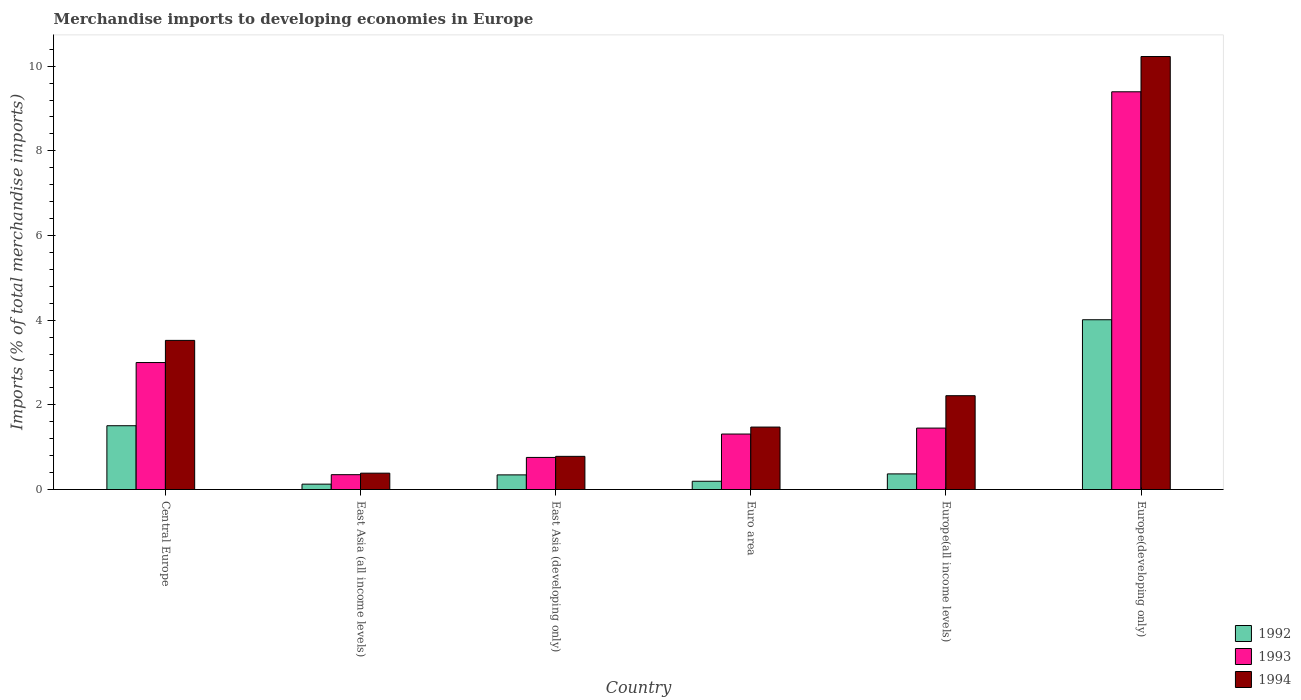How many groups of bars are there?
Provide a short and direct response. 6. How many bars are there on the 5th tick from the left?
Give a very brief answer. 3. What is the label of the 4th group of bars from the left?
Make the answer very short. Euro area. In how many cases, is the number of bars for a given country not equal to the number of legend labels?
Provide a short and direct response. 0. What is the percentage total merchandise imports in 1992 in Euro area?
Your answer should be compact. 0.2. Across all countries, what is the maximum percentage total merchandise imports in 1994?
Your answer should be very brief. 10.23. Across all countries, what is the minimum percentage total merchandise imports in 1992?
Offer a terse response. 0.13. In which country was the percentage total merchandise imports in 1994 maximum?
Ensure brevity in your answer.  Europe(developing only). In which country was the percentage total merchandise imports in 1993 minimum?
Ensure brevity in your answer.  East Asia (all income levels). What is the total percentage total merchandise imports in 1993 in the graph?
Ensure brevity in your answer.  16.26. What is the difference between the percentage total merchandise imports in 1994 in Euro area and that in Europe(developing only)?
Offer a terse response. -8.75. What is the difference between the percentage total merchandise imports in 1993 in East Asia (all income levels) and the percentage total merchandise imports in 1994 in Central Europe?
Your response must be concise. -3.17. What is the average percentage total merchandise imports in 1992 per country?
Offer a terse response. 1.09. What is the difference between the percentage total merchandise imports of/in 1994 and percentage total merchandise imports of/in 1993 in East Asia (developing only)?
Provide a short and direct response. 0.03. In how many countries, is the percentage total merchandise imports in 1992 greater than 9.6 %?
Give a very brief answer. 0. What is the ratio of the percentage total merchandise imports in 1993 in Euro area to that in Europe(developing only)?
Give a very brief answer. 0.14. Is the percentage total merchandise imports in 1994 in Central Europe less than that in Europe(developing only)?
Offer a terse response. Yes. Is the difference between the percentage total merchandise imports in 1994 in Euro area and Europe(developing only) greater than the difference between the percentage total merchandise imports in 1993 in Euro area and Europe(developing only)?
Offer a very short reply. No. What is the difference between the highest and the second highest percentage total merchandise imports in 1992?
Your response must be concise. -1.14. What is the difference between the highest and the lowest percentage total merchandise imports in 1993?
Provide a succinct answer. 9.04. What does the 1st bar from the right in Central Europe represents?
Your answer should be very brief. 1994. Are all the bars in the graph horizontal?
Offer a very short reply. No. How many countries are there in the graph?
Offer a terse response. 6. Are the values on the major ticks of Y-axis written in scientific E-notation?
Make the answer very short. No. Does the graph contain any zero values?
Provide a succinct answer. No. Does the graph contain grids?
Provide a short and direct response. No. Where does the legend appear in the graph?
Offer a very short reply. Bottom right. How many legend labels are there?
Provide a succinct answer. 3. What is the title of the graph?
Your response must be concise. Merchandise imports to developing economies in Europe. Does "1983" appear as one of the legend labels in the graph?
Offer a terse response. No. What is the label or title of the Y-axis?
Offer a terse response. Imports (% of total merchandise imports). What is the Imports (% of total merchandise imports) of 1992 in Central Europe?
Your answer should be compact. 1.51. What is the Imports (% of total merchandise imports) in 1993 in Central Europe?
Your answer should be very brief. 3. What is the Imports (% of total merchandise imports) of 1994 in Central Europe?
Offer a terse response. 3.52. What is the Imports (% of total merchandise imports) of 1992 in East Asia (all income levels)?
Offer a terse response. 0.13. What is the Imports (% of total merchandise imports) of 1993 in East Asia (all income levels)?
Offer a very short reply. 0.35. What is the Imports (% of total merchandise imports) in 1994 in East Asia (all income levels)?
Provide a succinct answer. 0.39. What is the Imports (% of total merchandise imports) of 1992 in East Asia (developing only)?
Your answer should be very brief. 0.35. What is the Imports (% of total merchandise imports) of 1993 in East Asia (developing only)?
Give a very brief answer. 0.76. What is the Imports (% of total merchandise imports) of 1994 in East Asia (developing only)?
Your answer should be very brief. 0.78. What is the Imports (% of total merchandise imports) of 1992 in Euro area?
Make the answer very short. 0.2. What is the Imports (% of total merchandise imports) in 1993 in Euro area?
Ensure brevity in your answer.  1.31. What is the Imports (% of total merchandise imports) of 1994 in Euro area?
Offer a terse response. 1.48. What is the Imports (% of total merchandise imports) of 1992 in Europe(all income levels)?
Your response must be concise. 0.37. What is the Imports (% of total merchandise imports) of 1993 in Europe(all income levels)?
Offer a terse response. 1.45. What is the Imports (% of total merchandise imports) in 1994 in Europe(all income levels)?
Your response must be concise. 2.22. What is the Imports (% of total merchandise imports) in 1992 in Europe(developing only)?
Offer a terse response. 4.01. What is the Imports (% of total merchandise imports) of 1993 in Europe(developing only)?
Give a very brief answer. 9.39. What is the Imports (% of total merchandise imports) of 1994 in Europe(developing only)?
Give a very brief answer. 10.23. Across all countries, what is the maximum Imports (% of total merchandise imports) in 1992?
Provide a succinct answer. 4.01. Across all countries, what is the maximum Imports (% of total merchandise imports) in 1993?
Provide a short and direct response. 9.39. Across all countries, what is the maximum Imports (% of total merchandise imports) of 1994?
Ensure brevity in your answer.  10.23. Across all countries, what is the minimum Imports (% of total merchandise imports) of 1992?
Provide a succinct answer. 0.13. Across all countries, what is the minimum Imports (% of total merchandise imports) in 1993?
Offer a very short reply. 0.35. Across all countries, what is the minimum Imports (% of total merchandise imports) of 1994?
Your response must be concise. 0.39. What is the total Imports (% of total merchandise imports) in 1992 in the graph?
Ensure brevity in your answer.  6.55. What is the total Imports (% of total merchandise imports) in 1993 in the graph?
Give a very brief answer. 16.26. What is the total Imports (% of total merchandise imports) of 1994 in the graph?
Give a very brief answer. 18.61. What is the difference between the Imports (% of total merchandise imports) in 1992 in Central Europe and that in East Asia (all income levels)?
Provide a short and direct response. 1.38. What is the difference between the Imports (% of total merchandise imports) in 1993 in Central Europe and that in East Asia (all income levels)?
Offer a very short reply. 2.65. What is the difference between the Imports (% of total merchandise imports) of 1994 in Central Europe and that in East Asia (all income levels)?
Make the answer very short. 3.14. What is the difference between the Imports (% of total merchandise imports) in 1992 in Central Europe and that in East Asia (developing only)?
Provide a short and direct response. 1.16. What is the difference between the Imports (% of total merchandise imports) in 1993 in Central Europe and that in East Asia (developing only)?
Your answer should be very brief. 2.24. What is the difference between the Imports (% of total merchandise imports) of 1994 in Central Europe and that in East Asia (developing only)?
Give a very brief answer. 2.74. What is the difference between the Imports (% of total merchandise imports) in 1992 in Central Europe and that in Euro area?
Offer a very short reply. 1.31. What is the difference between the Imports (% of total merchandise imports) in 1993 in Central Europe and that in Euro area?
Provide a succinct answer. 1.69. What is the difference between the Imports (% of total merchandise imports) of 1994 in Central Europe and that in Euro area?
Provide a succinct answer. 2.05. What is the difference between the Imports (% of total merchandise imports) of 1992 in Central Europe and that in Europe(all income levels)?
Offer a terse response. 1.14. What is the difference between the Imports (% of total merchandise imports) of 1993 in Central Europe and that in Europe(all income levels)?
Your response must be concise. 1.55. What is the difference between the Imports (% of total merchandise imports) in 1994 in Central Europe and that in Europe(all income levels)?
Your answer should be compact. 1.31. What is the difference between the Imports (% of total merchandise imports) in 1992 in Central Europe and that in Europe(developing only)?
Offer a terse response. -2.5. What is the difference between the Imports (% of total merchandise imports) of 1993 in Central Europe and that in Europe(developing only)?
Keep it short and to the point. -6.4. What is the difference between the Imports (% of total merchandise imports) in 1994 in Central Europe and that in Europe(developing only)?
Provide a short and direct response. -6.7. What is the difference between the Imports (% of total merchandise imports) in 1992 in East Asia (all income levels) and that in East Asia (developing only)?
Keep it short and to the point. -0.22. What is the difference between the Imports (% of total merchandise imports) of 1993 in East Asia (all income levels) and that in East Asia (developing only)?
Your response must be concise. -0.41. What is the difference between the Imports (% of total merchandise imports) of 1994 in East Asia (all income levels) and that in East Asia (developing only)?
Ensure brevity in your answer.  -0.4. What is the difference between the Imports (% of total merchandise imports) of 1992 in East Asia (all income levels) and that in Euro area?
Give a very brief answer. -0.07. What is the difference between the Imports (% of total merchandise imports) of 1993 in East Asia (all income levels) and that in Euro area?
Give a very brief answer. -0.96. What is the difference between the Imports (% of total merchandise imports) in 1994 in East Asia (all income levels) and that in Euro area?
Ensure brevity in your answer.  -1.09. What is the difference between the Imports (% of total merchandise imports) of 1992 in East Asia (all income levels) and that in Europe(all income levels)?
Provide a succinct answer. -0.24. What is the difference between the Imports (% of total merchandise imports) of 1993 in East Asia (all income levels) and that in Europe(all income levels)?
Your response must be concise. -1.1. What is the difference between the Imports (% of total merchandise imports) of 1994 in East Asia (all income levels) and that in Europe(all income levels)?
Your answer should be very brief. -1.83. What is the difference between the Imports (% of total merchandise imports) of 1992 in East Asia (all income levels) and that in Europe(developing only)?
Keep it short and to the point. -3.88. What is the difference between the Imports (% of total merchandise imports) of 1993 in East Asia (all income levels) and that in Europe(developing only)?
Ensure brevity in your answer.  -9.04. What is the difference between the Imports (% of total merchandise imports) of 1994 in East Asia (all income levels) and that in Europe(developing only)?
Offer a terse response. -9.84. What is the difference between the Imports (% of total merchandise imports) of 1992 in East Asia (developing only) and that in Euro area?
Your response must be concise. 0.15. What is the difference between the Imports (% of total merchandise imports) of 1993 in East Asia (developing only) and that in Euro area?
Provide a short and direct response. -0.55. What is the difference between the Imports (% of total merchandise imports) of 1994 in East Asia (developing only) and that in Euro area?
Provide a succinct answer. -0.69. What is the difference between the Imports (% of total merchandise imports) of 1992 in East Asia (developing only) and that in Europe(all income levels)?
Ensure brevity in your answer.  -0.02. What is the difference between the Imports (% of total merchandise imports) of 1993 in East Asia (developing only) and that in Europe(all income levels)?
Make the answer very short. -0.69. What is the difference between the Imports (% of total merchandise imports) of 1994 in East Asia (developing only) and that in Europe(all income levels)?
Offer a terse response. -1.43. What is the difference between the Imports (% of total merchandise imports) in 1992 in East Asia (developing only) and that in Europe(developing only)?
Provide a short and direct response. -3.66. What is the difference between the Imports (% of total merchandise imports) of 1993 in East Asia (developing only) and that in Europe(developing only)?
Offer a very short reply. -8.64. What is the difference between the Imports (% of total merchandise imports) of 1994 in East Asia (developing only) and that in Europe(developing only)?
Ensure brevity in your answer.  -9.44. What is the difference between the Imports (% of total merchandise imports) in 1992 in Euro area and that in Europe(all income levels)?
Provide a short and direct response. -0.17. What is the difference between the Imports (% of total merchandise imports) of 1993 in Euro area and that in Europe(all income levels)?
Make the answer very short. -0.14. What is the difference between the Imports (% of total merchandise imports) in 1994 in Euro area and that in Europe(all income levels)?
Provide a short and direct response. -0.74. What is the difference between the Imports (% of total merchandise imports) of 1992 in Euro area and that in Europe(developing only)?
Ensure brevity in your answer.  -3.82. What is the difference between the Imports (% of total merchandise imports) in 1993 in Euro area and that in Europe(developing only)?
Your answer should be compact. -8.08. What is the difference between the Imports (% of total merchandise imports) of 1994 in Euro area and that in Europe(developing only)?
Your response must be concise. -8.75. What is the difference between the Imports (% of total merchandise imports) of 1992 in Europe(all income levels) and that in Europe(developing only)?
Give a very brief answer. -3.64. What is the difference between the Imports (% of total merchandise imports) in 1993 in Europe(all income levels) and that in Europe(developing only)?
Offer a terse response. -7.94. What is the difference between the Imports (% of total merchandise imports) of 1994 in Europe(all income levels) and that in Europe(developing only)?
Your answer should be compact. -8.01. What is the difference between the Imports (% of total merchandise imports) of 1992 in Central Europe and the Imports (% of total merchandise imports) of 1993 in East Asia (all income levels)?
Offer a terse response. 1.16. What is the difference between the Imports (% of total merchandise imports) in 1992 in Central Europe and the Imports (% of total merchandise imports) in 1994 in East Asia (all income levels)?
Your response must be concise. 1.12. What is the difference between the Imports (% of total merchandise imports) of 1993 in Central Europe and the Imports (% of total merchandise imports) of 1994 in East Asia (all income levels)?
Your response must be concise. 2.61. What is the difference between the Imports (% of total merchandise imports) of 1992 in Central Europe and the Imports (% of total merchandise imports) of 1993 in East Asia (developing only)?
Your answer should be compact. 0.75. What is the difference between the Imports (% of total merchandise imports) in 1992 in Central Europe and the Imports (% of total merchandise imports) in 1994 in East Asia (developing only)?
Ensure brevity in your answer.  0.72. What is the difference between the Imports (% of total merchandise imports) in 1993 in Central Europe and the Imports (% of total merchandise imports) in 1994 in East Asia (developing only)?
Your response must be concise. 2.22. What is the difference between the Imports (% of total merchandise imports) of 1992 in Central Europe and the Imports (% of total merchandise imports) of 1993 in Euro area?
Provide a short and direct response. 0.2. What is the difference between the Imports (% of total merchandise imports) of 1992 in Central Europe and the Imports (% of total merchandise imports) of 1994 in Euro area?
Your answer should be very brief. 0.03. What is the difference between the Imports (% of total merchandise imports) in 1993 in Central Europe and the Imports (% of total merchandise imports) in 1994 in Euro area?
Offer a terse response. 1.52. What is the difference between the Imports (% of total merchandise imports) in 1992 in Central Europe and the Imports (% of total merchandise imports) in 1993 in Europe(all income levels)?
Ensure brevity in your answer.  0.06. What is the difference between the Imports (% of total merchandise imports) in 1992 in Central Europe and the Imports (% of total merchandise imports) in 1994 in Europe(all income levels)?
Offer a very short reply. -0.71. What is the difference between the Imports (% of total merchandise imports) in 1993 in Central Europe and the Imports (% of total merchandise imports) in 1994 in Europe(all income levels)?
Make the answer very short. 0.78. What is the difference between the Imports (% of total merchandise imports) of 1992 in Central Europe and the Imports (% of total merchandise imports) of 1993 in Europe(developing only)?
Provide a short and direct response. -7.89. What is the difference between the Imports (% of total merchandise imports) of 1992 in Central Europe and the Imports (% of total merchandise imports) of 1994 in Europe(developing only)?
Give a very brief answer. -8.72. What is the difference between the Imports (% of total merchandise imports) in 1993 in Central Europe and the Imports (% of total merchandise imports) in 1994 in Europe(developing only)?
Provide a short and direct response. -7.23. What is the difference between the Imports (% of total merchandise imports) in 1992 in East Asia (all income levels) and the Imports (% of total merchandise imports) in 1993 in East Asia (developing only)?
Offer a terse response. -0.63. What is the difference between the Imports (% of total merchandise imports) in 1992 in East Asia (all income levels) and the Imports (% of total merchandise imports) in 1994 in East Asia (developing only)?
Offer a terse response. -0.66. What is the difference between the Imports (% of total merchandise imports) of 1993 in East Asia (all income levels) and the Imports (% of total merchandise imports) of 1994 in East Asia (developing only)?
Give a very brief answer. -0.43. What is the difference between the Imports (% of total merchandise imports) of 1992 in East Asia (all income levels) and the Imports (% of total merchandise imports) of 1993 in Euro area?
Your answer should be compact. -1.18. What is the difference between the Imports (% of total merchandise imports) in 1992 in East Asia (all income levels) and the Imports (% of total merchandise imports) in 1994 in Euro area?
Your answer should be compact. -1.35. What is the difference between the Imports (% of total merchandise imports) of 1993 in East Asia (all income levels) and the Imports (% of total merchandise imports) of 1994 in Euro area?
Your answer should be very brief. -1.12. What is the difference between the Imports (% of total merchandise imports) in 1992 in East Asia (all income levels) and the Imports (% of total merchandise imports) in 1993 in Europe(all income levels)?
Your answer should be very brief. -1.32. What is the difference between the Imports (% of total merchandise imports) in 1992 in East Asia (all income levels) and the Imports (% of total merchandise imports) in 1994 in Europe(all income levels)?
Make the answer very short. -2.09. What is the difference between the Imports (% of total merchandise imports) in 1993 in East Asia (all income levels) and the Imports (% of total merchandise imports) in 1994 in Europe(all income levels)?
Offer a terse response. -1.87. What is the difference between the Imports (% of total merchandise imports) in 1992 in East Asia (all income levels) and the Imports (% of total merchandise imports) in 1993 in Europe(developing only)?
Offer a terse response. -9.27. What is the difference between the Imports (% of total merchandise imports) in 1992 in East Asia (all income levels) and the Imports (% of total merchandise imports) in 1994 in Europe(developing only)?
Provide a short and direct response. -10.1. What is the difference between the Imports (% of total merchandise imports) of 1993 in East Asia (all income levels) and the Imports (% of total merchandise imports) of 1994 in Europe(developing only)?
Offer a terse response. -9.88. What is the difference between the Imports (% of total merchandise imports) in 1992 in East Asia (developing only) and the Imports (% of total merchandise imports) in 1993 in Euro area?
Provide a short and direct response. -0.96. What is the difference between the Imports (% of total merchandise imports) in 1992 in East Asia (developing only) and the Imports (% of total merchandise imports) in 1994 in Euro area?
Give a very brief answer. -1.13. What is the difference between the Imports (% of total merchandise imports) in 1993 in East Asia (developing only) and the Imports (% of total merchandise imports) in 1994 in Euro area?
Offer a very short reply. -0.72. What is the difference between the Imports (% of total merchandise imports) of 1992 in East Asia (developing only) and the Imports (% of total merchandise imports) of 1993 in Europe(all income levels)?
Your answer should be very brief. -1.11. What is the difference between the Imports (% of total merchandise imports) in 1992 in East Asia (developing only) and the Imports (% of total merchandise imports) in 1994 in Europe(all income levels)?
Provide a succinct answer. -1.87. What is the difference between the Imports (% of total merchandise imports) of 1993 in East Asia (developing only) and the Imports (% of total merchandise imports) of 1994 in Europe(all income levels)?
Keep it short and to the point. -1.46. What is the difference between the Imports (% of total merchandise imports) in 1992 in East Asia (developing only) and the Imports (% of total merchandise imports) in 1993 in Europe(developing only)?
Keep it short and to the point. -9.05. What is the difference between the Imports (% of total merchandise imports) in 1992 in East Asia (developing only) and the Imports (% of total merchandise imports) in 1994 in Europe(developing only)?
Your answer should be very brief. -9.88. What is the difference between the Imports (% of total merchandise imports) in 1993 in East Asia (developing only) and the Imports (% of total merchandise imports) in 1994 in Europe(developing only)?
Keep it short and to the point. -9.47. What is the difference between the Imports (% of total merchandise imports) in 1992 in Euro area and the Imports (% of total merchandise imports) in 1993 in Europe(all income levels)?
Give a very brief answer. -1.26. What is the difference between the Imports (% of total merchandise imports) in 1992 in Euro area and the Imports (% of total merchandise imports) in 1994 in Europe(all income levels)?
Offer a very short reply. -2.02. What is the difference between the Imports (% of total merchandise imports) of 1993 in Euro area and the Imports (% of total merchandise imports) of 1994 in Europe(all income levels)?
Keep it short and to the point. -0.91. What is the difference between the Imports (% of total merchandise imports) in 1992 in Euro area and the Imports (% of total merchandise imports) in 1993 in Europe(developing only)?
Offer a terse response. -9.2. What is the difference between the Imports (% of total merchandise imports) in 1992 in Euro area and the Imports (% of total merchandise imports) in 1994 in Europe(developing only)?
Your response must be concise. -10.03. What is the difference between the Imports (% of total merchandise imports) in 1993 in Euro area and the Imports (% of total merchandise imports) in 1994 in Europe(developing only)?
Your answer should be very brief. -8.92. What is the difference between the Imports (% of total merchandise imports) of 1992 in Europe(all income levels) and the Imports (% of total merchandise imports) of 1993 in Europe(developing only)?
Offer a very short reply. -9.03. What is the difference between the Imports (% of total merchandise imports) of 1992 in Europe(all income levels) and the Imports (% of total merchandise imports) of 1994 in Europe(developing only)?
Give a very brief answer. -9.86. What is the difference between the Imports (% of total merchandise imports) in 1993 in Europe(all income levels) and the Imports (% of total merchandise imports) in 1994 in Europe(developing only)?
Give a very brief answer. -8.78. What is the average Imports (% of total merchandise imports) in 1992 per country?
Offer a very short reply. 1.09. What is the average Imports (% of total merchandise imports) of 1993 per country?
Provide a succinct answer. 2.71. What is the average Imports (% of total merchandise imports) of 1994 per country?
Give a very brief answer. 3.1. What is the difference between the Imports (% of total merchandise imports) in 1992 and Imports (% of total merchandise imports) in 1993 in Central Europe?
Your answer should be very brief. -1.49. What is the difference between the Imports (% of total merchandise imports) in 1992 and Imports (% of total merchandise imports) in 1994 in Central Europe?
Provide a short and direct response. -2.02. What is the difference between the Imports (% of total merchandise imports) in 1993 and Imports (% of total merchandise imports) in 1994 in Central Europe?
Offer a very short reply. -0.52. What is the difference between the Imports (% of total merchandise imports) of 1992 and Imports (% of total merchandise imports) of 1993 in East Asia (all income levels)?
Your answer should be very brief. -0.22. What is the difference between the Imports (% of total merchandise imports) of 1992 and Imports (% of total merchandise imports) of 1994 in East Asia (all income levels)?
Make the answer very short. -0.26. What is the difference between the Imports (% of total merchandise imports) in 1993 and Imports (% of total merchandise imports) in 1994 in East Asia (all income levels)?
Keep it short and to the point. -0.04. What is the difference between the Imports (% of total merchandise imports) of 1992 and Imports (% of total merchandise imports) of 1993 in East Asia (developing only)?
Make the answer very short. -0.41. What is the difference between the Imports (% of total merchandise imports) of 1992 and Imports (% of total merchandise imports) of 1994 in East Asia (developing only)?
Offer a very short reply. -0.44. What is the difference between the Imports (% of total merchandise imports) of 1993 and Imports (% of total merchandise imports) of 1994 in East Asia (developing only)?
Ensure brevity in your answer.  -0.03. What is the difference between the Imports (% of total merchandise imports) of 1992 and Imports (% of total merchandise imports) of 1993 in Euro area?
Your answer should be compact. -1.12. What is the difference between the Imports (% of total merchandise imports) in 1992 and Imports (% of total merchandise imports) in 1994 in Euro area?
Make the answer very short. -1.28. What is the difference between the Imports (% of total merchandise imports) of 1993 and Imports (% of total merchandise imports) of 1994 in Euro area?
Your answer should be very brief. -0.16. What is the difference between the Imports (% of total merchandise imports) in 1992 and Imports (% of total merchandise imports) in 1993 in Europe(all income levels)?
Your answer should be compact. -1.08. What is the difference between the Imports (% of total merchandise imports) of 1992 and Imports (% of total merchandise imports) of 1994 in Europe(all income levels)?
Provide a short and direct response. -1.85. What is the difference between the Imports (% of total merchandise imports) in 1993 and Imports (% of total merchandise imports) in 1994 in Europe(all income levels)?
Make the answer very short. -0.76. What is the difference between the Imports (% of total merchandise imports) in 1992 and Imports (% of total merchandise imports) in 1993 in Europe(developing only)?
Provide a succinct answer. -5.38. What is the difference between the Imports (% of total merchandise imports) of 1992 and Imports (% of total merchandise imports) of 1994 in Europe(developing only)?
Provide a succinct answer. -6.22. What is the difference between the Imports (% of total merchandise imports) of 1993 and Imports (% of total merchandise imports) of 1994 in Europe(developing only)?
Your answer should be very brief. -0.83. What is the ratio of the Imports (% of total merchandise imports) of 1992 in Central Europe to that in East Asia (all income levels)?
Offer a terse response. 11.88. What is the ratio of the Imports (% of total merchandise imports) of 1993 in Central Europe to that in East Asia (all income levels)?
Give a very brief answer. 8.56. What is the ratio of the Imports (% of total merchandise imports) in 1994 in Central Europe to that in East Asia (all income levels)?
Your answer should be compact. 9.11. What is the ratio of the Imports (% of total merchandise imports) in 1992 in Central Europe to that in East Asia (developing only)?
Offer a very short reply. 4.36. What is the ratio of the Imports (% of total merchandise imports) of 1993 in Central Europe to that in East Asia (developing only)?
Offer a terse response. 3.96. What is the ratio of the Imports (% of total merchandise imports) in 1994 in Central Europe to that in East Asia (developing only)?
Ensure brevity in your answer.  4.5. What is the ratio of the Imports (% of total merchandise imports) of 1992 in Central Europe to that in Euro area?
Your answer should be compact. 7.72. What is the ratio of the Imports (% of total merchandise imports) in 1993 in Central Europe to that in Euro area?
Offer a terse response. 2.29. What is the ratio of the Imports (% of total merchandise imports) in 1994 in Central Europe to that in Euro area?
Offer a very short reply. 2.39. What is the ratio of the Imports (% of total merchandise imports) in 1992 in Central Europe to that in Europe(all income levels)?
Ensure brevity in your answer.  4.09. What is the ratio of the Imports (% of total merchandise imports) in 1993 in Central Europe to that in Europe(all income levels)?
Provide a succinct answer. 2.07. What is the ratio of the Imports (% of total merchandise imports) in 1994 in Central Europe to that in Europe(all income levels)?
Keep it short and to the point. 1.59. What is the ratio of the Imports (% of total merchandise imports) in 1992 in Central Europe to that in Europe(developing only)?
Offer a very short reply. 0.38. What is the ratio of the Imports (% of total merchandise imports) in 1993 in Central Europe to that in Europe(developing only)?
Offer a terse response. 0.32. What is the ratio of the Imports (% of total merchandise imports) in 1994 in Central Europe to that in Europe(developing only)?
Give a very brief answer. 0.34. What is the ratio of the Imports (% of total merchandise imports) of 1992 in East Asia (all income levels) to that in East Asia (developing only)?
Keep it short and to the point. 0.37. What is the ratio of the Imports (% of total merchandise imports) in 1993 in East Asia (all income levels) to that in East Asia (developing only)?
Your answer should be very brief. 0.46. What is the ratio of the Imports (% of total merchandise imports) of 1994 in East Asia (all income levels) to that in East Asia (developing only)?
Provide a succinct answer. 0.49. What is the ratio of the Imports (% of total merchandise imports) in 1992 in East Asia (all income levels) to that in Euro area?
Your answer should be very brief. 0.65. What is the ratio of the Imports (% of total merchandise imports) of 1993 in East Asia (all income levels) to that in Euro area?
Give a very brief answer. 0.27. What is the ratio of the Imports (% of total merchandise imports) of 1994 in East Asia (all income levels) to that in Euro area?
Keep it short and to the point. 0.26. What is the ratio of the Imports (% of total merchandise imports) of 1992 in East Asia (all income levels) to that in Europe(all income levels)?
Provide a succinct answer. 0.34. What is the ratio of the Imports (% of total merchandise imports) in 1993 in East Asia (all income levels) to that in Europe(all income levels)?
Offer a terse response. 0.24. What is the ratio of the Imports (% of total merchandise imports) in 1994 in East Asia (all income levels) to that in Europe(all income levels)?
Ensure brevity in your answer.  0.17. What is the ratio of the Imports (% of total merchandise imports) of 1992 in East Asia (all income levels) to that in Europe(developing only)?
Offer a very short reply. 0.03. What is the ratio of the Imports (% of total merchandise imports) in 1993 in East Asia (all income levels) to that in Europe(developing only)?
Ensure brevity in your answer.  0.04. What is the ratio of the Imports (% of total merchandise imports) in 1994 in East Asia (all income levels) to that in Europe(developing only)?
Provide a short and direct response. 0.04. What is the ratio of the Imports (% of total merchandise imports) of 1992 in East Asia (developing only) to that in Euro area?
Give a very brief answer. 1.77. What is the ratio of the Imports (% of total merchandise imports) of 1993 in East Asia (developing only) to that in Euro area?
Ensure brevity in your answer.  0.58. What is the ratio of the Imports (% of total merchandise imports) in 1994 in East Asia (developing only) to that in Euro area?
Provide a succinct answer. 0.53. What is the ratio of the Imports (% of total merchandise imports) in 1992 in East Asia (developing only) to that in Europe(all income levels)?
Keep it short and to the point. 0.94. What is the ratio of the Imports (% of total merchandise imports) of 1993 in East Asia (developing only) to that in Europe(all income levels)?
Keep it short and to the point. 0.52. What is the ratio of the Imports (% of total merchandise imports) of 1994 in East Asia (developing only) to that in Europe(all income levels)?
Make the answer very short. 0.35. What is the ratio of the Imports (% of total merchandise imports) in 1992 in East Asia (developing only) to that in Europe(developing only)?
Make the answer very short. 0.09. What is the ratio of the Imports (% of total merchandise imports) of 1993 in East Asia (developing only) to that in Europe(developing only)?
Your answer should be compact. 0.08. What is the ratio of the Imports (% of total merchandise imports) in 1994 in East Asia (developing only) to that in Europe(developing only)?
Your answer should be compact. 0.08. What is the ratio of the Imports (% of total merchandise imports) in 1992 in Euro area to that in Europe(all income levels)?
Your answer should be very brief. 0.53. What is the ratio of the Imports (% of total merchandise imports) in 1993 in Euro area to that in Europe(all income levels)?
Make the answer very short. 0.9. What is the ratio of the Imports (% of total merchandise imports) of 1994 in Euro area to that in Europe(all income levels)?
Ensure brevity in your answer.  0.67. What is the ratio of the Imports (% of total merchandise imports) of 1992 in Euro area to that in Europe(developing only)?
Provide a short and direct response. 0.05. What is the ratio of the Imports (% of total merchandise imports) of 1993 in Euro area to that in Europe(developing only)?
Offer a terse response. 0.14. What is the ratio of the Imports (% of total merchandise imports) in 1994 in Euro area to that in Europe(developing only)?
Offer a very short reply. 0.14. What is the ratio of the Imports (% of total merchandise imports) of 1992 in Europe(all income levels) to that in Europe(developing only)?
Your answer should be compact. 0.09. What is the ratio of the Imports (% of total merchandise imports) of 1993 in Europe(all income levels) to that in Europe(developing only)?
Offer a very short reply. 0.15. What is the ratio of the Imports (% of total merchandise imports) of 1994 in Europe(all income levels) to that in Europe(developing only)?
Provide a succinct answer. 0.22. What is the difference between the highest and the second highest Imports (% of total merchandise imports) of 1992?
Your answer should be compact. 2.5. What is the difference between the highest and the second highest Imports (% of total merchandise imports) in 1993?
Provide a short and direct response. 6.4. What is the difference between the highest and the second highest Imports (% of total merchandise imports) of 1994?
Your answer should be very brief. 6.7. What is the difference between the highest and the lowest Imports (% of total merchandise imports) in 1992?
Offer a very short reply. 3.88. What is the difference between the highest and the lowest Imports (% of total merchandise imports) in 1993?
Your answer should be compact. 9.04. What is the difference between the highest and the lowest Imports (% of total merchandise imports) of 1994?
Your answer should be very brief. 9.84. 